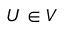Convert formula to latex. <formula><loc_0><loc_0><loc_500><loc_500>U \in V</formula> 